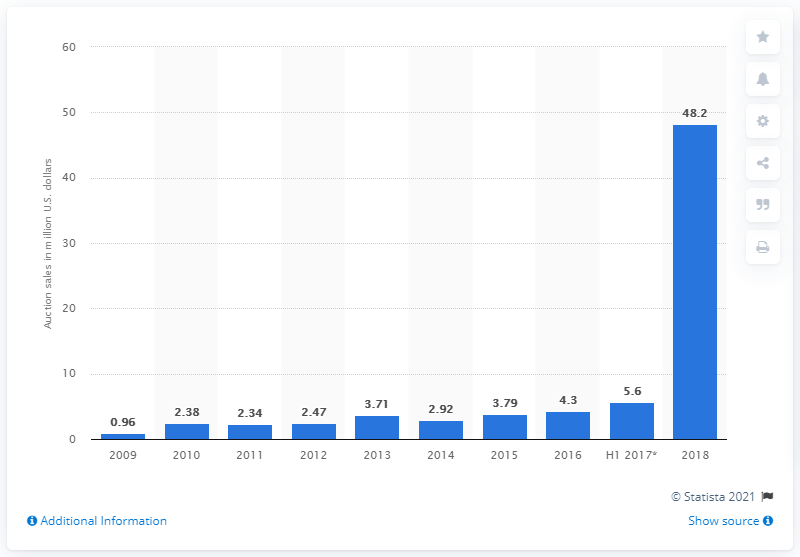Draw attention to some important aspects in this diagram. The total value of contemporary art auction sales in Africa between 2009 and 2018 was 48.2 billion dollars. 